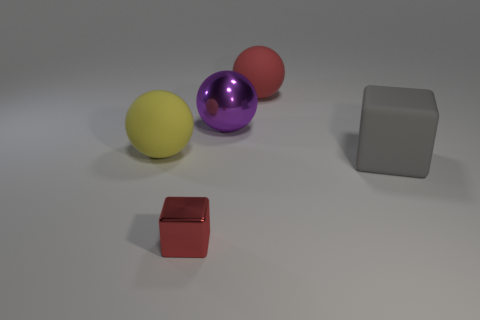If this image was part of a children's learning activity, what could be a potential lesson? This image could be used in several ways for children's education. For example, a lesson on colors and shapes, where children identify different colors and count the number of geometrical shapes. Another lesson could involve spatial recognition, asking children to describe how objects are positioned in relation to each other. 